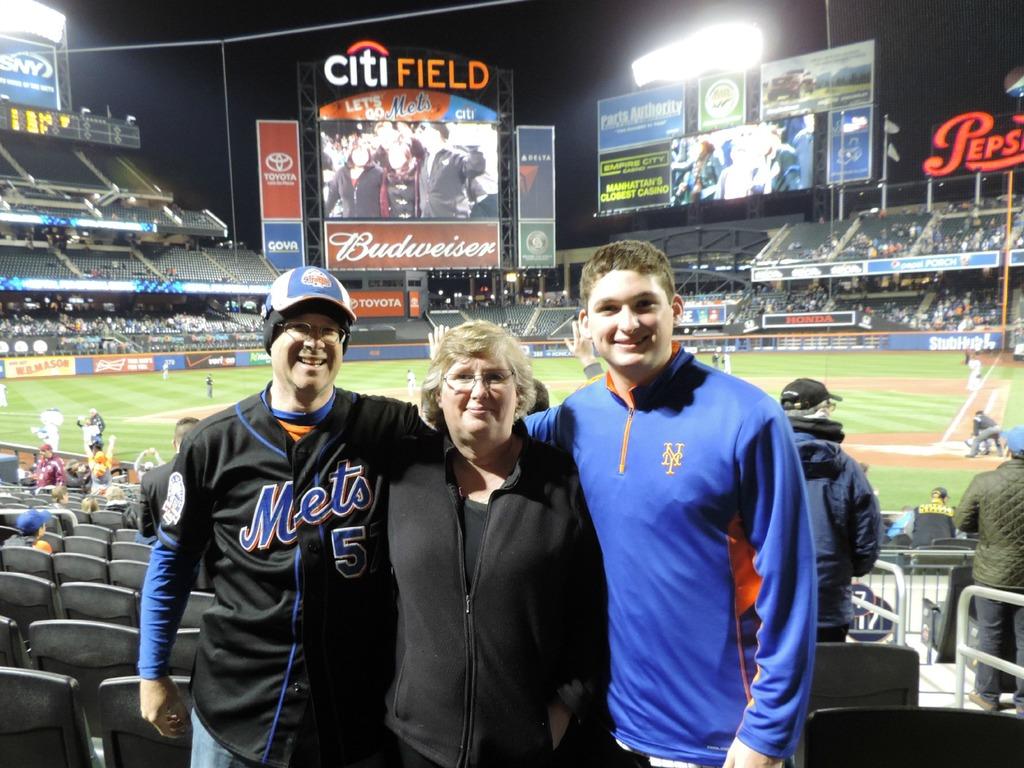What is the name of the field the picture as taken?
Ensure brevity in your answer.  Citi field. What beer company is on the big screen?
Offer a very short reply. Budweiser. 